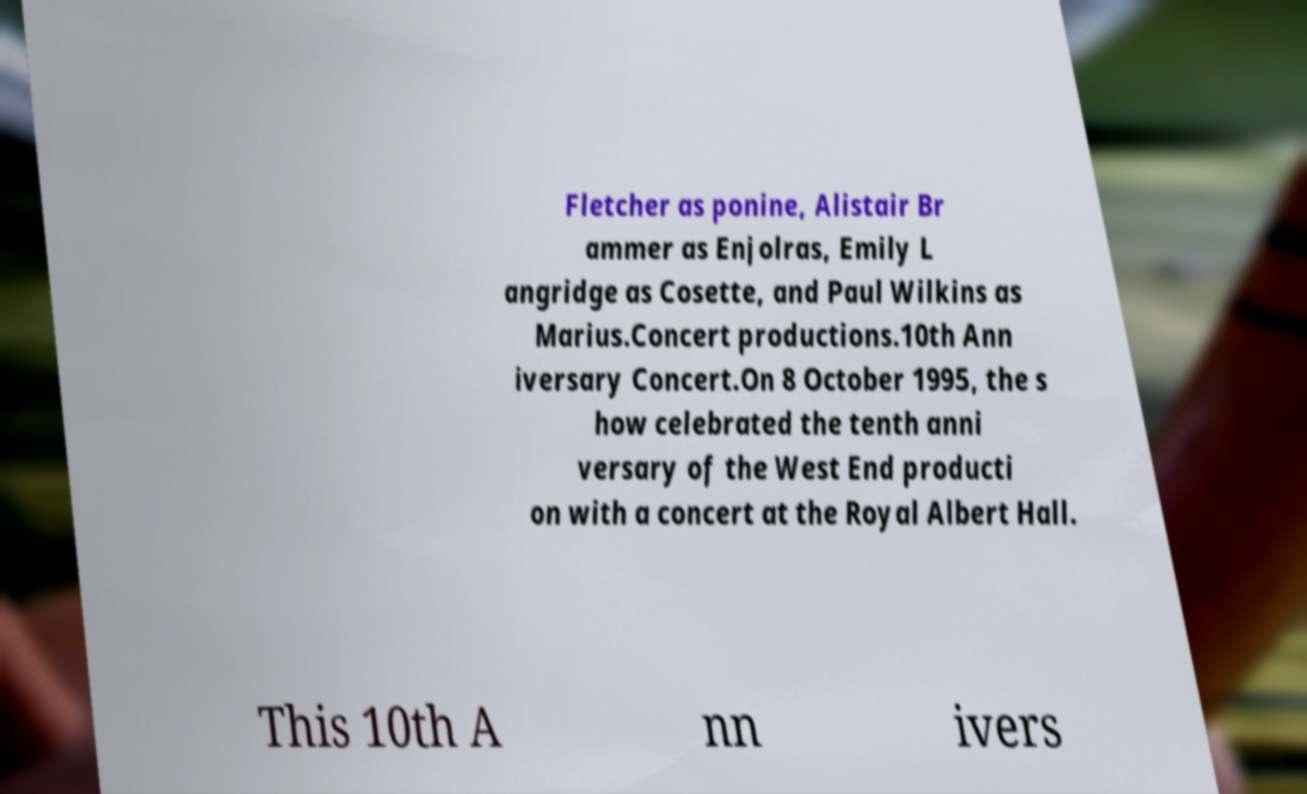Please identify and transcribe the text found in this image. Fletcher as ponine, Alistair Br ammer as Enjolras, Emily L angridge as Cosette, and Paul Wilkins as Marius.Concert productions.10th Ann iversary Concert.On 8 October 1995, the s how celebrated the tenth anni versary of the West End producti on with a concert at the Royal Albert Hall. This 10th A nn ivers 